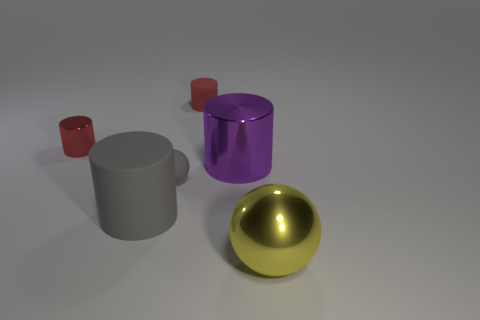Subtract all purple cylinders. How many cylinders are left? 3 Add 3 large gray cylinders. How many objects exist? 9 Subtract all red cylinders. How many cylinders are left? 2 Subtract 1 spheres. How many spheres are left? 1 Subtract all large yellow objects. Subtract all small gray things. How many objects are left? 4 Add 4 small balls. How many small balls are left? 5 Add 1 big purple metallic balls. How many big purple metallic balls exist? 1 Subtract 1 gray cylinders. How many objects are left? 5 Subtract all balls. How many objects are left? 4 Subtract all purple balls. Subtract all brown cubes. How many balls are left? 2 